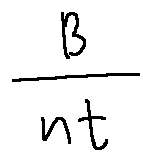<formula> <loc_0><loc_0><loc_500><loc_500>\frac { B } { n t }</formula> 